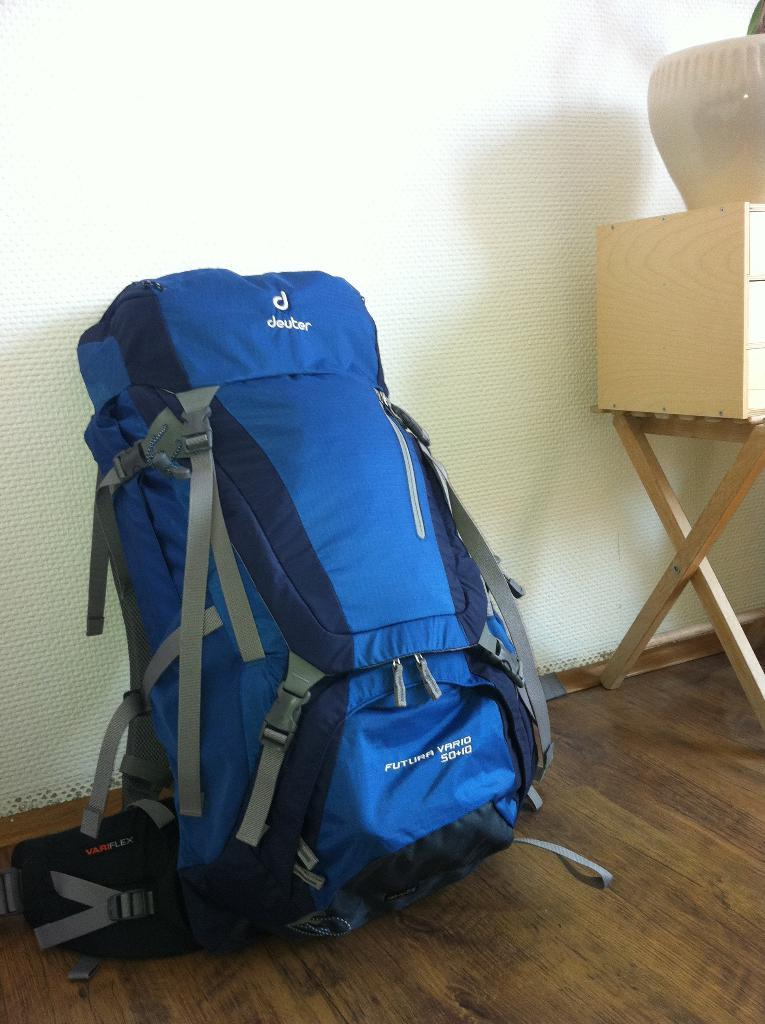What color is the bag that is visible in the image? The bag is blue in color. Where is the bag located in the image? The bag is on the floor. What other furniture or objects can be seen in the image? There is a table in the image. What is on the table in the image? There is an object on the table. What can be seen in the background of the image? There is a wall visible in the background of the image. What type of flesh can be seen on the table in the image? There is no flesh present on the table in the image. What meal is being prepared on the table in the image? There is no meal preparation visible in the image; it only shows a table with an object on it. 